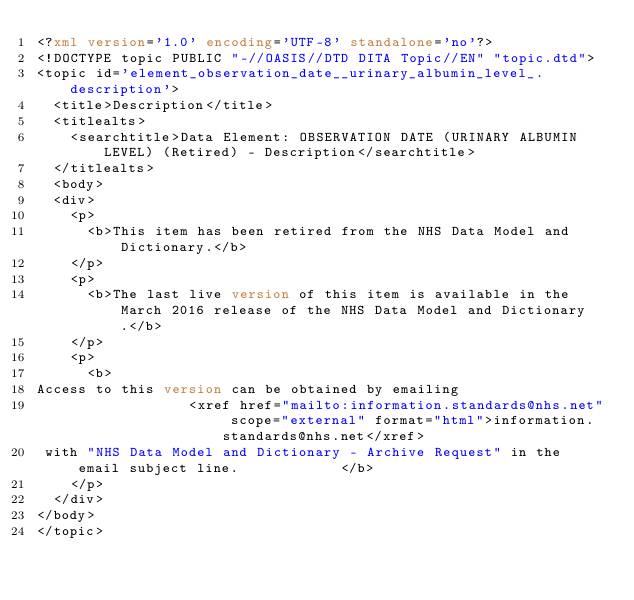Convert code to text. <code><loc_0><loc_0><loc_500><loc_500><_XML_><?xml version='1.0' encoding='UTF-8' standalone='no'?>
<!DOCTYPE topic PUBLIC "-//OASIS//DTD DITA Topic//EN" "topic.dtd">
<topic id='element_observation_date__urinary_albumin_level_.description'>
  <title>Description</title>
  <titlealts>
    <searchtitle>Data Element: OBSERVATION DATE (URINARY ALBUMIN LEVEL) (Retired) - Description</searchtitle>
  </titlealts>
  <body>
  <div>
    <p>
      <b>This item has been retired from the NHS Data Model and Dictionary.</b>
    </p>
    <p>
      <b>The last live version of this item is available in the March 2016 release of the NHS Data Model and Dictionary.</b>
    </p>
    <p>
      <b>
Access to this version can be obtained by emailing 
                  <xref href="mailto:information.standards@nhs.net" scope="external" format="html">information.standards@nhs.net</xref>
 with "NHS Data Model and Dictionary - Archive Request" in the email subject line.            </b>
    </p>
  </div>
</body>
</topic></code> 